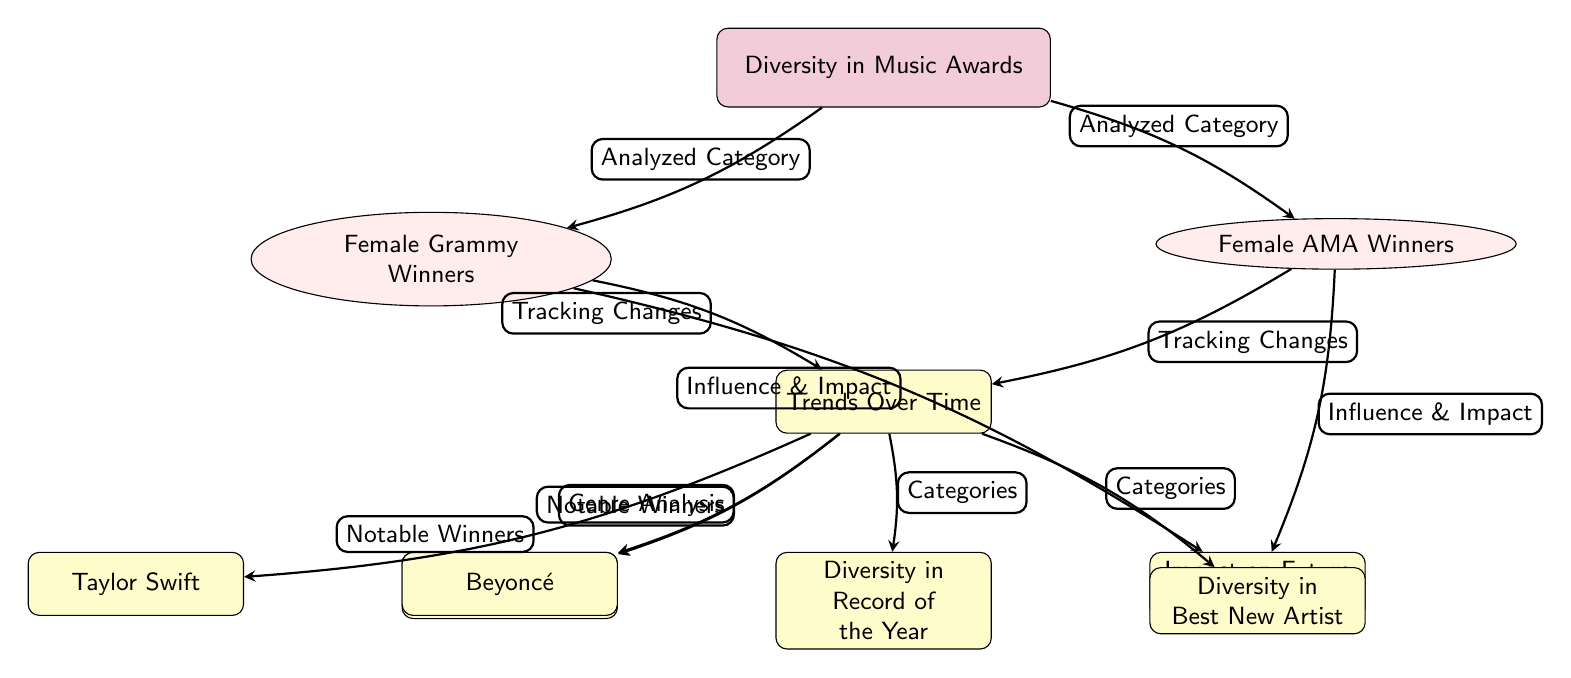What are the two main categories analyzed in the diagram? The diagram shows two main categories which are "Female Grammy Winners" and "Female AMA Winners." These are the primary distinctions at the second level, directly connected to the main node.
Answer: Female Grammy Winners, Female AMA Winners How many notable female winners are identified in the trends over time? Under the trends over time node, the notable winners mentioned are Beyoncé and Taylor Swift. Thus, there are two notable winners.
Answer: 2 What is the main focus of the edge connecting the main node to the second level nodes? The edge connects the main node "Diversity in Music Awards" to the second-level nodes "Female Grammy Winners" and "Female AMA Winners" indicating that these are both analyzed categories.
Answer: Analyzed Category Which analysis focuses on the genres of awarded women? The genre analysis related to the awarded women is explicitly connected to the node titled "Genres of Awarded Women," which is situated under the "Trends Over Time" node.
Answer: Genres of Awarded Women How does the diagram indicate the influence and impact of female winners? The diagram shows that both "Female Grammy Winners" and "Female AMA Winners" connect to the node "Impact on Future Generations," thus indicating these winners influence future generations.
Answer: Influence & Impact What categories are tracked in the trends over time connection? The diagram specifies that "Diversity in Record of the Year" and "Diversity in Best New Artist" are the categories explored in the trends over time, connected to the node below it.
Answer: Diversity in Record of the Year, Diversity in Best New Artist What is the relationship between notable winners and their influence? The notable winners Beyoncé and Taylor Swift are shown to have an influence linked to the node "Impact on Future Generations," indicating that their success impacts future female artists.
Answer: Influence & Impact Which two branches analyze changes over time for awards? The analysis of changes over time branches from the second-level nodes "Female Grammy Winners" and "Female AMA Winners," highlighting that both categories are being tracked for changes.
Answer: Tracking Changes 